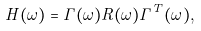<formula> <loc_0><loc_0><loc_500><loc_500>H ( \omega ) = \Gamma ( \omega ) R ( \omega ) \Gamma ^ { T } ( \omega ) ,</formula> 